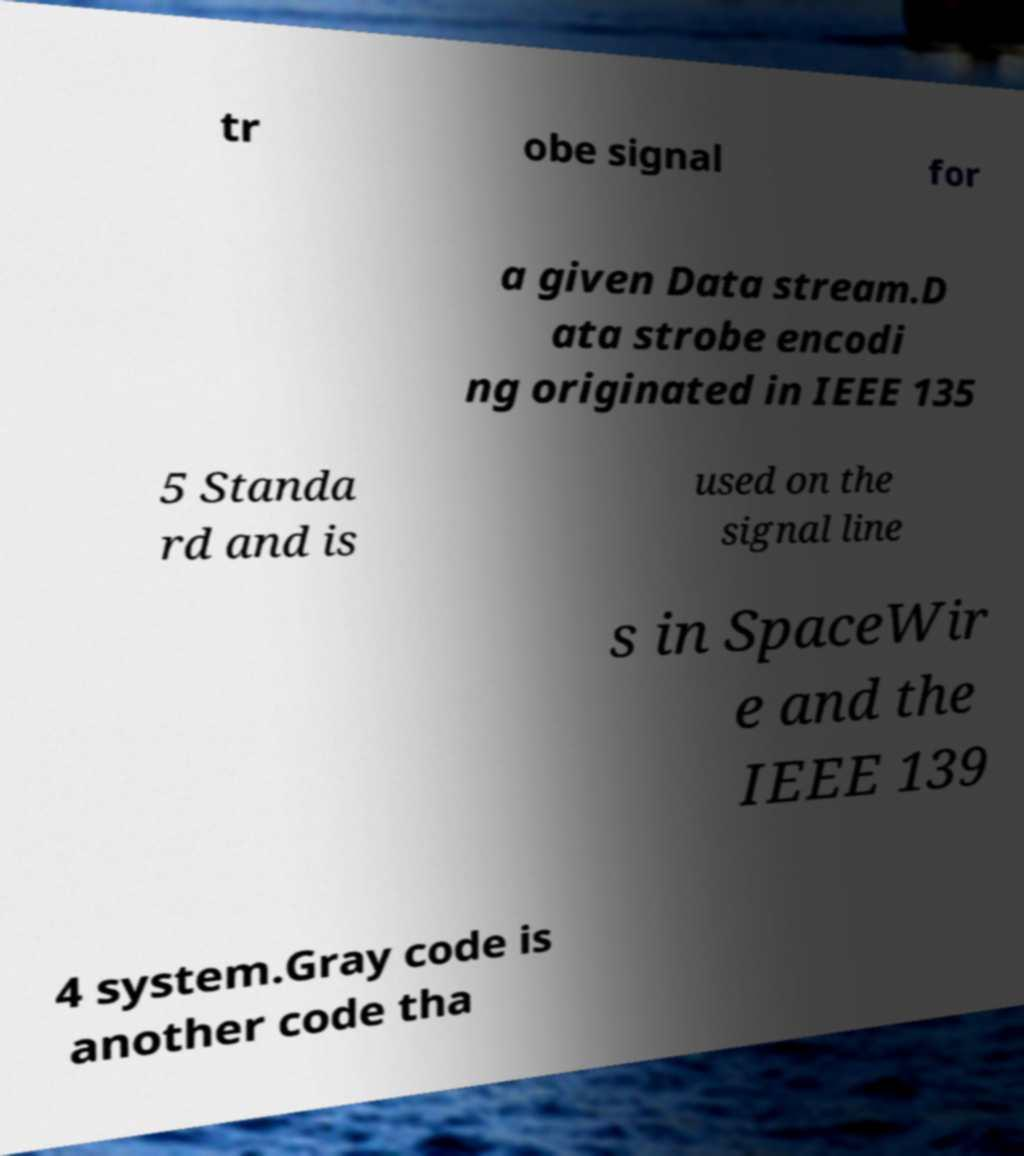Can you accurately transcribe the text from the provided image for me? tr obe signal for a given Data stream.D ata strobe encodi ng originated in IEEE 135 5 Standa rd and is used on the signal line s in SpaceWir e and the IEEE 139 4 system.Gray code is another code tha 